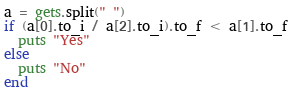<code> <loc_0><loc_0><loc_500><loc_500><_Ruby_>a = gets.split(" ")
if (a[0].to_i / a[2].to_i).to_f < a[1].to_f
  puts "Yes"
else
  puts "No"
end
</code> 